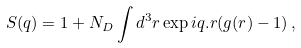Convert formula to latex. <formula><loc_0><loc_0><loc_500><loc_500>S ( q ) = 1 + N _ { D } \int d ^ { 3 } r \exp { i { q } . { r } } ( g ( r ) - 1 ) \, ,</formula> 